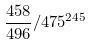<formula> <loc_0><loc_0><loc_500><loc_500>\frac { 4 5 8 } { 4 9 6 } / 4 7 5 ^ { 2 4 5 }</formula> 